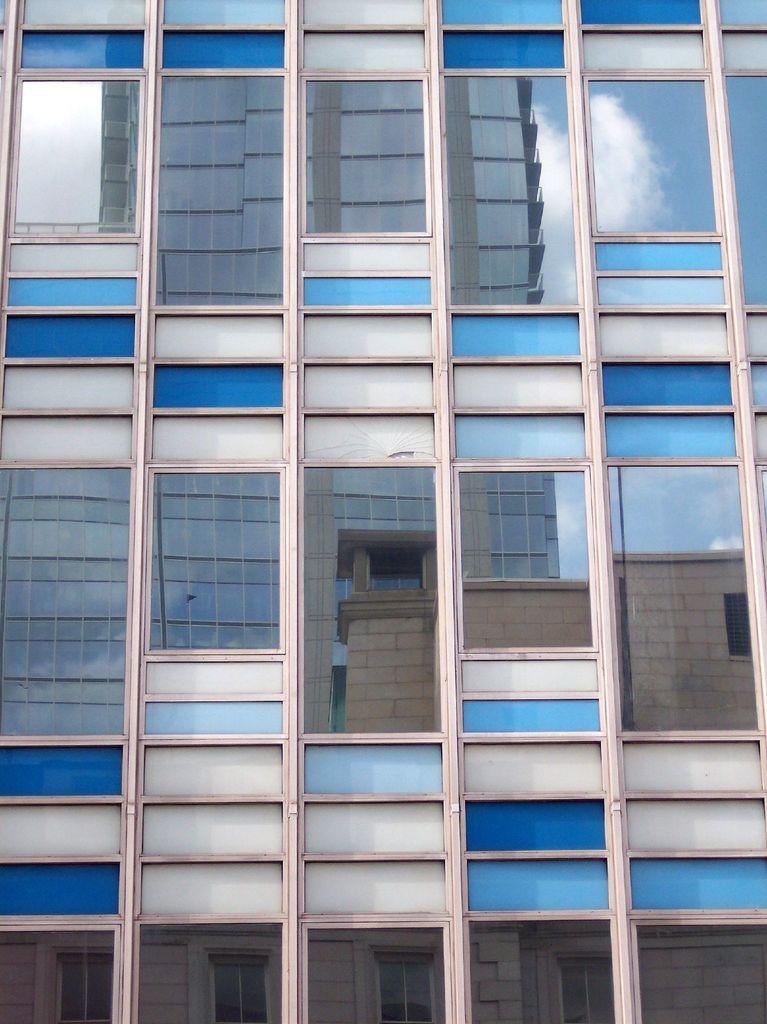Can you describe this image briefly? In this image I can see the building which is in white and blue color. I can also see the glasses to the building. Through the glass I can see an another building, clouds and the sky. 